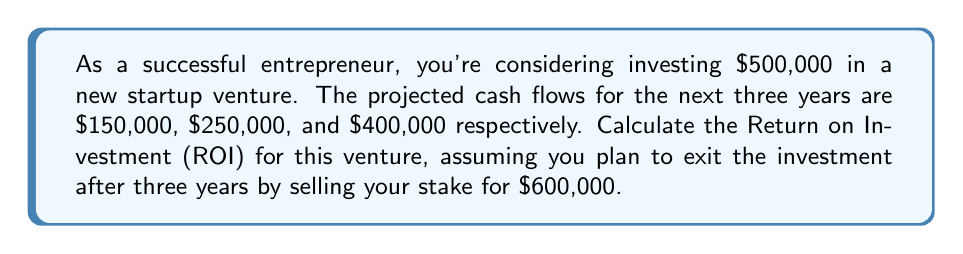Solve this math problem. To calculate the Return on Investment (ROI) for this startup venture, we need to follow these steps:

1. Calculate the total cash inflows:
   - Sum of projected cash flows: $150,000 + $250,000 + $400,000 = $800,000
   - Exit value: $600,000
   - Total cash inflows: $800,000 + $600,000 = $1,400,000

2. Calculate the total profit:
   Profit = Total cash inflows - Initial investment
   $$\text{Profit} = $1,400,000 - $500,000 = $900,000$$

3. Calculate the ROI using the formula:
   $$\text{ROI} = \frac{\text{Profit}}{\text{Initial Investment}} \times 100\%$$

   Substituting the values:
   $$\text{ROI} = \frac{$900,000}{$500,000} \times 100\%$$
   $$\text{ROI} = 1.8 \times 100\% = 180\%$$

This means that over the three-year period, your initial investment of $500,000 would generate a return of 180%.

To annualize this return, we can use the Compound Annual Growth Rate (CAGR) formula:

$$\text{CAGR} = \left(\frac{\text{Ending Value}}{\text{Beginning Value}}\right)^{\frac{1}{\text{Number of Years}}} - 1$$

$$\text{CAGR} = \left(\frac{$1,400,000}{$500,000}\right)^{\frac{1}{3}} - 1$$
$$\text{CAGR} = (2.8)^{\frac{1}{3}} - 1 \approx 0.4114 \text{ or } 41.14\%$$

This indicates an annualized return of approximately 41.14% over the three-year period.
Answer: The Return on Investment (ROI) for the startup venture is 180%, with an annualized return (CAGR) of approximately 41.14%. 